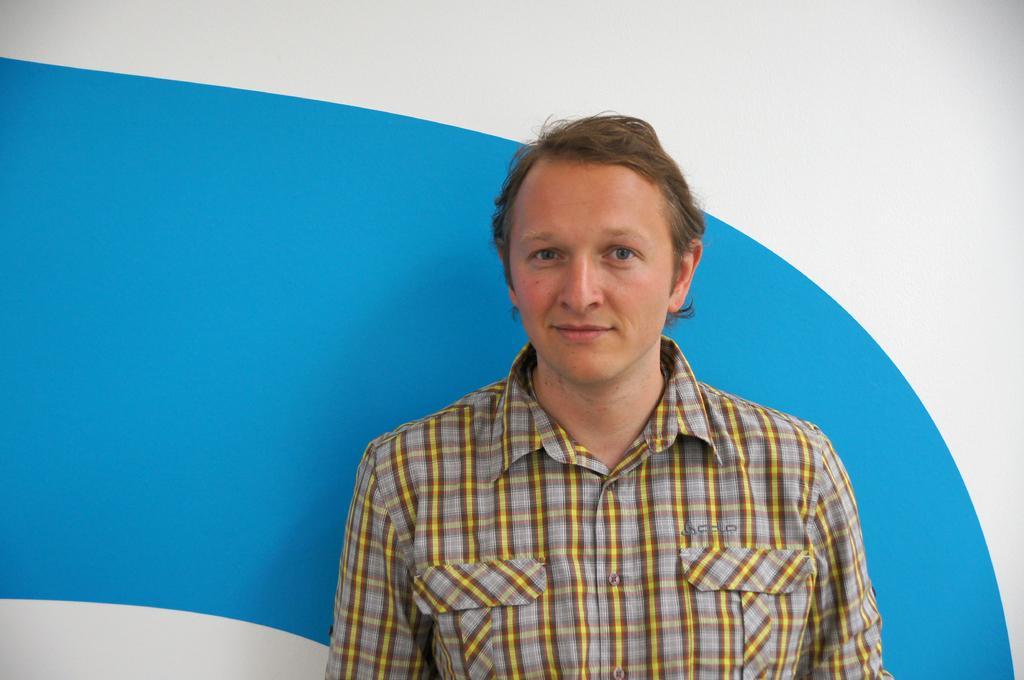Please provide a concise description of this image. This image consists of a man standing. In the background, we can see a wall in blue and white color. 